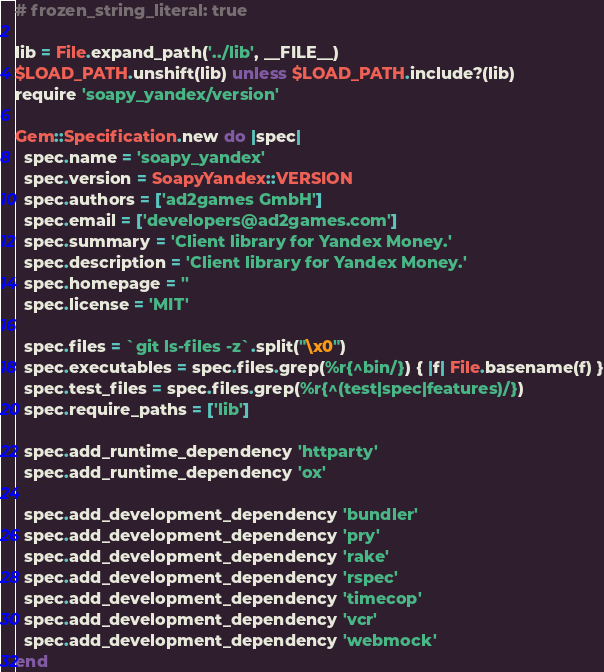<code> <loc_0><loc_0><loc_500><loc_500><_Ruby_># frozen_string_literal: true

lib = File.expand_path('../lib', __FILE__)
$LOAD_PATH.unshift(lib) unless $LOAD_PATH.include?(lib)
require 'soapy_yandex/version'

Gem::Specification.new do |spec|
  spec.name = 'soapy_yandex'
  spec.version = SoapyYandex::VERSION
  spec.authors = ['ad2games GmbH']
  spec.email = ['developers@ad2games.com']
  spec.summary = 'Client library for Yandex Money.'
  spec.description = 'Client library for Yandex Money.'
  spec.homepage = ''
  spec.license = 'MIT'

  spec.files = `git ls-files -z`.split("\x0")
  spec.executables = spec.files.grep(%r{^bin/}) { |f| File.basename(f) }
  spec.test_files = spec.files.grep(%r{^(test|spec|features)/})
  spec.require_paths = ['lib']

  spec.add_runtime_dependency 'httparty'
  spec.add_runtime_dependency 'ox'

  spec.add_development_dependency 'bundler'
  spec.add_development_dependency 'pry'
  spec.add_development_dependency 'rake'
  spec.add_development_dependency 'rspec'
  spec.add_development_dependency 'timecop'
  spec.add_development_dependency 'vcr'
  spec.add_development_dependency 'webmock'
end
</code> 